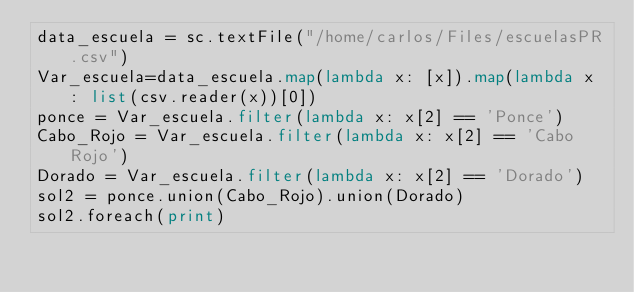<code> <loc_0><loc_0><loc_500><loc_500><_Python_>data_escuela = sc.textFile("/home/carlos/Files/escuelasPR.csv")
Var_escuela=data_escuela.map(lambda x: [x]).map(lambda x : list(csv.reader(x))[0])
ponce = Var_escuela.filter(lambda x: x[2] == 'Ponce')
Cabo_Rojo = Var_escuela.filter(lambda x: x[2] == 'Cabo Rojo')
Dorado = Var_escuela.filter(lambda x: x[2] == 'Dorado')
sol2 = ponce.union(Cabo_Rojo).union(Dorado)
sol2.foreach(print)
</code> 